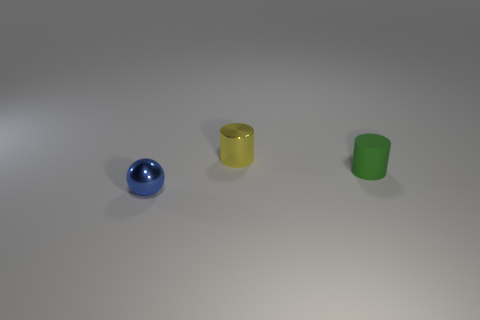What size is the blue object that is made of the same material as the yellow object?
Give a very brief answer. Small. Are the tiny object that is in front of the tiny matte cylinder and the tiny thing that is behind the green cylinder made of the same material?
Offer a terse response. Yes. How many cylinders are small blue things or matte things?
Give a very brief answer. 1. There is a small thing that is on the left side of the tiny metallic thing that is behind the small matte cylinder; how many metallic objects are behind it?
Your response must be concise. 1. There is a tiny green object that is the same shape as the yellow shiny thing; what is its material?
Provide a short and direct response. Rubber. Are there any other things that are made of the same material as the small blue ball?
Keep it short and to the point. Yes. What color is the shiny object that is behind the small blue metal sphere?
Give a very brief answer. Yellow. Does the tiny ball have the same material as the cylinder on the left side of the matte cylinder?
Keep it short and to the point. Yes. What is the sphere made of?
Keep it short and to the point. Metal. The tiny yellow object that is the same material as the tiny blue sphere is what shape?
Provide a short and direct response. Cylinder. 